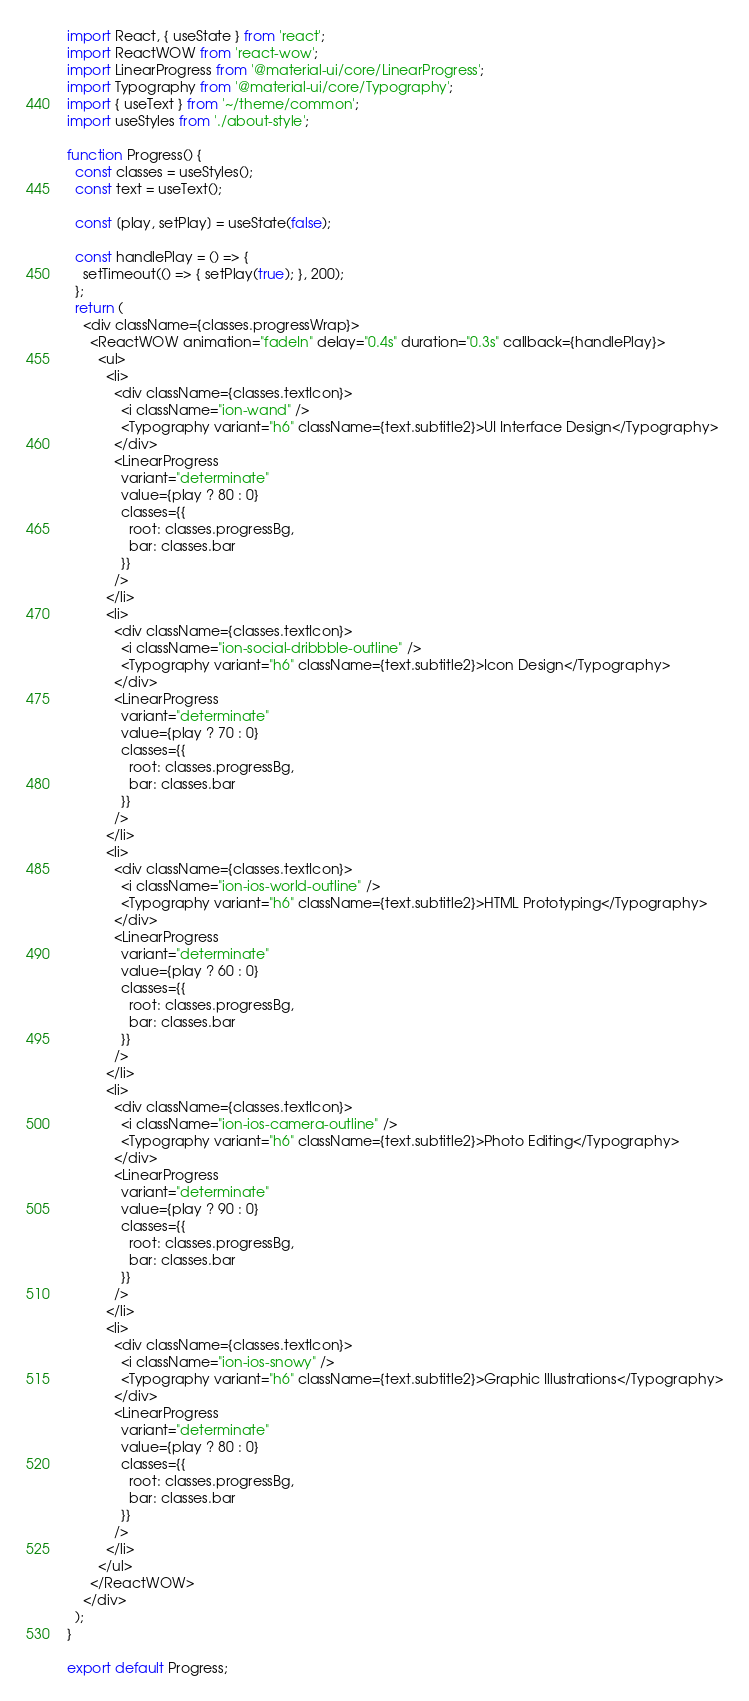<code> <loc_0><loc_0><loc_500><loc_500><_JavaScript_>import React, { useState } from 'react';
import ReactWOW from 'react-wow';
import LinearProgress from '@material-ui/core/LinearProgress';
import Typography from '@material-ui/core/Typography';
import { useText } from '~/theme/common';
import useStyles from './about-style';

function Progress() {
  const classes = useStyles();
  const text = useText();

  const [play, setPlay] = useState(false);

  const handlePlay = () => {
    setTimeout(() => { setPlay(true); }, 200);
  };
  return (
    <div className={classes.progressWrap}>
      <ReactWOW animation="fadeIn" delay="0.4s" duration="0.3s" callback={handlePlay}>
        <ul>
          <li>
            <div className={classes.textIcon}>
              <i className="ion-wand" />
              <Typography variant="h6" className={text.subtitle2}>UI Interface Design</Typography>
            </div>
            <LinearProgress
              variant="determinate"
              value={play ? 80 : 0}
              classes={{
                root: classes.progressBg,
                bar: classes.bar
              }}
            />
          </li>
          <li>
            <div className={classes.textIcon}>
              <i className="ion-social-dribbble-outline" />
              <Typography variant="h6" className={text.subtitle2}>Icon Design</Typography>
            </div>
            <LinearProgress
              variant="determinate"
              value={play ? 70 : 0}
              classes={{
                root: classes.progressBg,
                bar: classes.bar
              }}
            />
          </li>
          <li>
            <div className={classes.textIcon}>
              <i className="ion-ios-world-outline" />
              <Typography variant="h6" className={text.subtitle2}>HTML Prototyping</Typography>
            </div>
            <LinearProgress
              variant="determinate"
              value={play ? 60 : 0}
              classes={{
                root: classes.progressBg,
                bar: classes.bar
              }}
            />
          </li>
          <li>
            <div className={classes.textIcon}>
              <i className="ion-ios-camera-outline" />
              <Typography variant="h6" className={text.subtitle2}>Photo Editing</Typography>
            </div>
            <LinearProgress
              variant="determinate"
              value={play ? 90 : 0}
              classes={{
                root: classes.progressBg,
                bar: classes.bar
              }}
            />
          </li>
          <li>
            <div className={classes.textIcon}>
              <i className="ion-ios-snowy" />
              <Typography variant="h6" className={text.subtitle2}>Graphic Illustrations</Typography>
            </div>
            <LinearProgress
              variant="determinate"
              value={play ? 80 : 0}
              classes={{
                root: classes.progressBg,
                bar: classes.bar
              }}
            />
          </li>
        </ul>
      </ReactWOW>
    </div>
  );
}

export default Progress;
</code> 